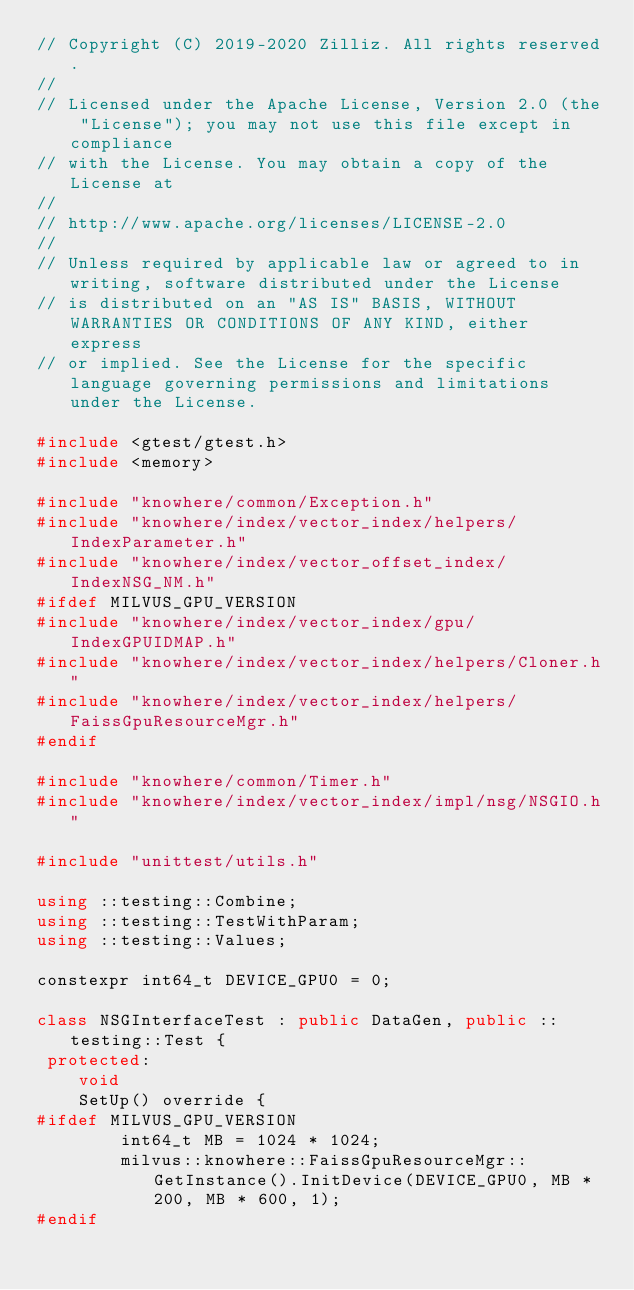<code> <loc_0><loc_0><loc_500><loc_500><_C++_>// Copyright (C) 2019-2020 Zilliz. All rights reserved.
//
// Licensed under the Apache License, Version 2.0 (the "License"); you may not use this file except in compliance
// with the License. You may obtain a copy of the License at
//
// http://www.apache.org/licenses/LICENSE-2.0
//
// Unless required by applicable law or agreed to in writing, software distributed under the License
// is distributed on an "AS IS" BASIS, WITHOUT WARRANTIES OR CONDITIONS OF ANY KIND, either express
// or implied. See the License for the specific language governing permissions and limitations under the License.

#include <gtest/gtest.h>
#include <memory>

#include "knowhere/common/Exception.h"
#include "knowhere/index/vector_index/helpers/IndexParameter.h"
#include "knowhere/index/vector_offset_index/IndexNSG_NM.h"
#ifdef MILVUS_GPU_VERSION
#include "knowhere/index/vector_index/gpu/IndexGPUIDMAP.h"
#include "knowhere/index/vector_index/helpers/Cloner.h"
#include "knowhere/index/vector_index/helpers/FaissGpuResourceMgr.h"
#endif

#include "knowhere/common/Timer.h"
#include "knowhere/index/vector_index/impl/nsg/NSGIO.h"

#include "unittest/utils.h"

using ::testing::Combine;
using ::testing::TestWithParam;
using ::testing::Values;

constexpr int64_t DEVICE_GPU0 = 0;

class NSGInterfaceTest : public DataGen, public ::testing::Test {
 protected:
    void
    SetUp() override {
#ifdef MILVUS_GPU_VERSION
        int64_t MB = 1024 * 1024;
        milvus::knowhere::FaissGpuResourceMgr::GetInstance().InitDevice(DEVICE_GPU0, MB * 200, MB * 600, 1);
#endif</code> 